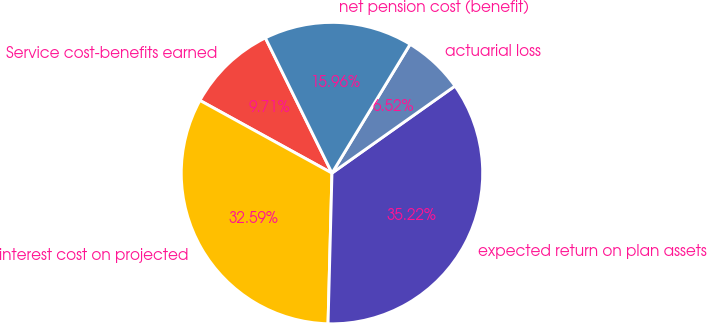Convert chart. <chart><loc_0><loc_0><loc_500><loc_500><pie_chart><fcel>Service cost-benefits earned<fcel>interest cost on projected<fcel>expected return on plan assets<fcel>actuarial loss<fcel>net pension cost (benefit)<nl><fcel>9.71%<fcel>32.59%<fcel>35.22%<fcel>6.52%<fcel>15.96%<nl></chart> 